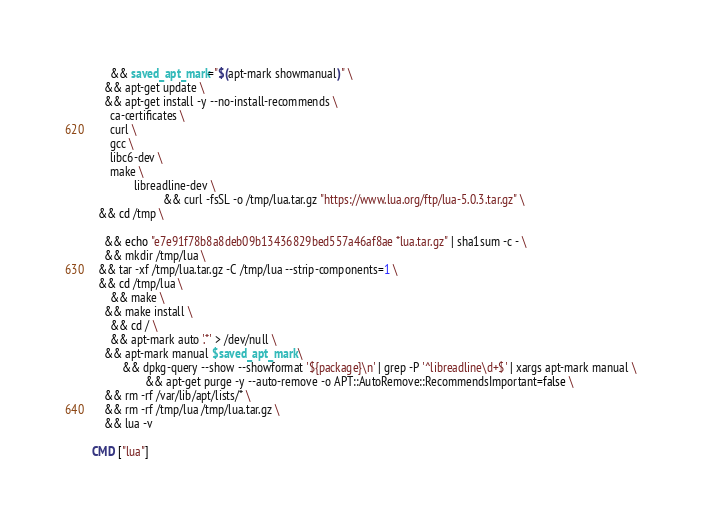<code> <loc_0><loc_0><loc_500><loc_500><_Dockerfile_>      && saved_apt_mark="$(apt-mark showmanual)" \
    && apt-get update \
    && apt-get install -y --no-install-recommends \
      ca-certificates \
      curl \
      gcc \
      libc6-dev \
      make \
              libreadline-dev \
                        && curl -fsSL -o /tmp/lua.tar.gz "https://www.lua.org/ftp/lua-5.0.3.tar.gz" \
  && cd /tmp \
  
    && echo "e7e91f78b8a8deb09b13436829bed557a46af8ae *lua.tar.gz" | sha1sum -c - \
    && mkdir /tmp/lua \
  && tar -xf /tmp/lua.tar.gz -C /tmp/lua --strip-components=1 \
  && cd /tmp/lua \
      && make \
    && make install \
      && cd / \
      && apt-mark auto '.*' > /dev/null \
    && apt-mark manual $saved_apt_mark \
          && dpkg-query --show --showformat '${package}\n' | grep -P '^libreadline\d+$' | xargs apt-mark manual \
                  && apt-get purge -y --auto-remove -o APT::AutoRemove::RecommendsImportant=false \
    && rm -rf /var/lib/apt/lists/* \
    && rm -rf /tmp/lua /tmp/lua.tar.gz \
    && lua -v

CMD ["lua"]
</code> 